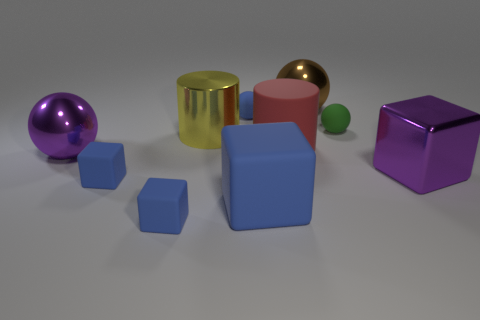What is the color of the big matte thing that is the same shape as the large yellow metallic object?
Make the answer very short. Red. What number of small things are either yellow metallic spheres or purple metal spheres?
Give a very brief answer. 0. What number of other things are there of the same color as the shiny cube?
Offer a terse response. 1. There is a rubber cube that is in front of the large object that is in front of the shiny block; what number of purple shiny balls are to the left of it?
Give a very brief answer. 1. Do the matte thing behind the green thing and the big yellow metal cylinder have the same size?
Provide a succinct answer. No. Is the number of blue rubber objects left of the big shiny cylinder less than the number of objects that are left of the small blue sphere?
Provide a succinct answer. Yes. Are there fewer blue matte blocks that are on the right side of the tiny blue matte sphere than small green rubber balls?
Your answer should be compact. No. What material is the tiny ball that is the same color as the big matte block?
Provide a succinct answer. Rubber. Does the small green ball have the same material as the large red thing?
Provide a succinct answer. Yes. How many green things have the same material as the red object?
Your answer should be very brief. 1. 